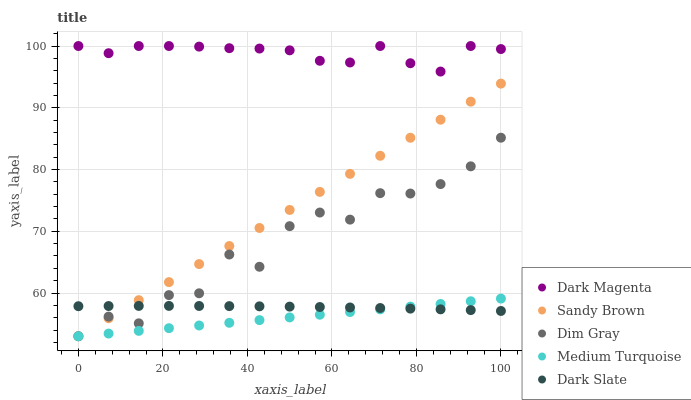Does Medium Turquoise have the minimum area under the curve?
Answer yes or no. Yes. Does Dark Magenta have the maximum area under the curve?
Answer yes or no. Yes. Does Dim Gray have the minimum area under the curve?
Answer yes or no. No. Does Dim Gray have the maximum area under the curve?
Answer yes or no. No. Is Medium Turquoise the smoothest?
Answer yes or no. Yes. Is Dim Gray the roughest?
Answer yes or no. Yes. Is Sandy Brown the smoothest?
Answer yes or no. No. Is Sandy Brown the roughest?
Answer yes or no. No. Does Dim Gray have the lowest value?
Answer yes or no. Yes. Does Dark Magenta have the lowest value?
Answer yes or no. No. Does Dark Magenta have the highest value?
Answer yes or no. Yes. Does Dim Gray have the highest value?
Answer yes or no. No. Is Sandy Brown less than Dark Magenta?
Answer yes or no. Yes. Is Dark Magenta greater than Dark Slate?
Answer yes or no. Yes. Does Medium Turquoise intersect Sandy Brown?
Answer yes or no. Yes. Is Medium Turquoise less than Sandy Brown?
Answer yes or no. No. Is Medium Turquoise greater than Sandy Brown?
Answer yes or no. No. Does Sandy Brown intersect Dark Magenta?
Answer yes or no. No. 